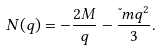Convert formula to latex. <formula><loc_0><loc_0><loc_500><loc_500>N ( q ) = - \frac { 2 M } q - \frac { \L m q ^ { 2 } } 3 .</formula> 